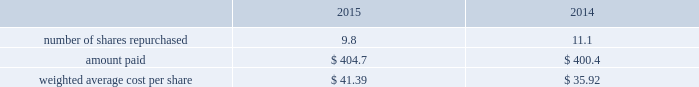Republic services , inc .
Notes to consolidated financial statements 2014 ( continued ) charges or other amounts due that are probable at settlement .
The aggregate cash surrender value of these life insurance policies was $ 90.5 million and $ 77.1 million as of december 31 , 2015 and 2014 , respectively , and is classified in other assets in our consolidated balance sheets .
The dcp liability was $ 83.3 million and $ 76.3 million as of december 31 , 2015 and 2014 , respectively , and is classified in other long-term liabilities in our consolidated balance sheets .
Employee stock purchase plan republic employees are eligible to participate in an employee stock purchase plan .
The plan allows participants to purchase our common stock for 95% ( 95 % ) of its quoted market price on the last day of each calendar quarter .
For the years ended december 31 , 2015 , 2014 and 2013 , issuances under this plan totaled 141055 shares , 139941 shares and 142217 shares , respectively .
As of december 31 , 2015 , shares reserved for issuance to employees under this plan totaled 0.6 million and republic held employee contributions of approximately $ 1.4 million for the purchase of common stock .
12 .
Stock repurchases and dividends stock repurchases stock repurchase activity during the years ended december 31 , 2015 and 2014 follows ( in millions except per share amounts ) : .
As of december 31 , 2015 , 0.1 million repurchased shares were pending settlement and $ 3.7 million were unpaid and included within our accrued liabilities .
In october 2015 , our board of directors added $ 900.0 million to the existing share repurchase authorization , which now extends through december 31 , 2017 .
Share repurchases under the program may be made through open market purchases or privately negotiated transactions in accordance with applicable federal securities laws .
While the board of directors has approved the program , the timing of any purchases , the prices and the number of shares of common stock to be purchased will be determined by our management , at its discretion , and will depend upon market conditions and other factors .
The share repurchase program may be extended , suspended or discontinued at any time .
As of december 31 , 2015 , the october 2015 repurchase program had remaining authorized purchase capacity of $ 855.5 million .
In december 2015 , our board of directors changed the status of 71272964 treasury shares to authorized and unissued .
In doing so , the number of our issued shares was reduced by the stated amount .
Our accounting policy is to deduct the par value from common stock and to reflect the excess of cost over par value as a deduction from additional paid-in capital .
The change in unissued shares resulted in a reduction of $ 2295.3 million in treasury stock , $ 0.6 million in common stock , and $ 2294.7 million in additional paid-in capital .
There was no effect on our total stockholders 2019 equity position as a result of the change .
Dividends in october 2015 , our board of directors approved a quarterly dividend of $ 0.30 per share .
Cash dividends declared were $ 404.3 million , $ 383.6 million and $ 357.3 million for the years ended december 31 , 2015 , 2014 and 2013 , respectively .
As of december 31 , 2015 , we recorded a quarterly dividend payable of $ 103.7 million to shareholders of record at the close of business on january 4 , 2016. .
What was the percent of the remaining purchase capacity of the october 2015 compared to the authorized? 
Rationale: the percent of the remainder to the authorized , you divide the remainder by the authorized
Computations: (855.5 / 900.0)
Answer: 0.95056. 